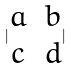Convert formula to latex. <formula><loc_0><loc_0><loc_500><loc_500>| \begin{matrix} a & b \\ c & d \end{matrix} |</formula> 